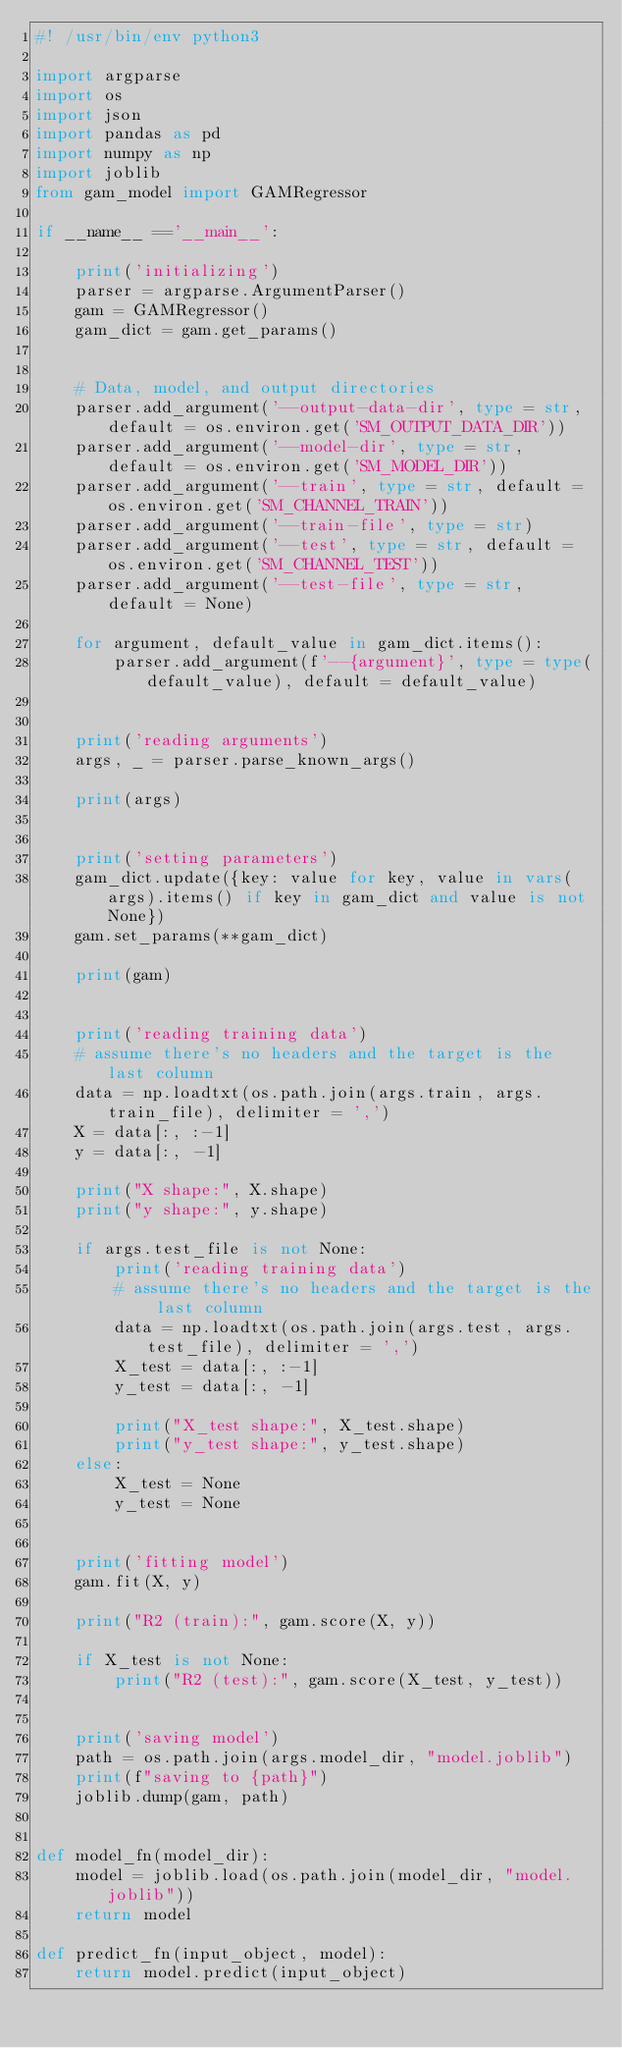<code> <loc_0><loc_0><loc_500><loc_500><_Python_>#! /usr/bin/env python3

import argparse
import os
import json
import pandas as pd
import numpy as np
import joblib
from gam_model import GAMRegressor

if __name__ =='__main__':

    print('initializing')
    parser = argparse.ArgumentParser()
    gam = GAMRegressor()
    gam_dict = gam.get_params()


    # Data, model, and output directories
    parser.add_argument('--output-data-dir', type = str, default = os.environ.get('SM_OUTPUT_DATA_DIR'))
    parser.add_argument('--model-dir', type = str, default = os.environ.get('SM_MODEL_DIR'))
    parser.add_argument('--train', type = str, default = os.environ.get('SM_CHANNEL_TRAIN'))
    parser.add_argument('--train-file', type = str)
    parser.add_argument('--test', type = str, default = os.environ.get('SM_CHANNEL_TEST'))
    parser.add_argument('--test-file', type = str, default = None)
    
    for argument, default_value in gam_dict.items():
        parser.add_argument(f'--{argument}', type = type(default_value), default = default_value)

        
    print('reading arguments')
    args, _ = parser.parse_known_args()

    print(args)
    
    
    print('setting parameters')
    gam_dict.update({key: value for key, value in vars(args).items() if key in gam_dict and value is not None})
    gam.set_params(**gam_dict)
    
    print(gam)

    
    print('reading training data') 
    # assume there's no headers and the target is the last column
    data = np.loadtxt(os.path.join(args.train, args.train_file), delimiter = ',')
    X = data[:, :-1]
    y = data[:, -1]
    
    print("X shape:", X.shape)
    print("y shape:", y.shape)

    if args.test_file is not None:
        print('reading training data') 
        # assume there's no headers and the target is the last column
        data = np.loadtxt(os.path.join(args.test, args.test_file), delimiter = ',')
        X_test = data[:, :-1]
        y_test = data[:, -1]

        print("X_test shape:", X_test.shape)
        print("y_test shape:", y_test.shape)
    else:
        X_test = None
        y_test = None
    
    
    print('fitting model') 
    gam.fit(X, y)
    
    print("R2 (train):", gam.score(X, y))
    
    if X_test is not None:
        print("R2 (test):", gam.score(X_test, y_test))
    

    print('saving model') 
    path = os.path.join(args.model_dir, "model.joblib")
    print(f"saving to {path}")
    joblib.dump(gam, path)


def model_fn(model_dir):
    model = joblib.load(os.path.join(model_dir, "model.joblib"))
    return model
    
def predict_fn(input_object, model):
    return model.predict(input_object)
</code> 